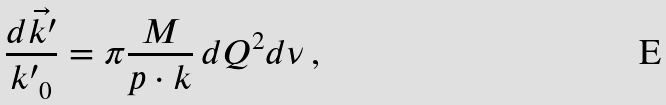<formula> <loc_0><loc_0><loc_500><loc_500>\frac { d \vec { k ^ { \prime } } } { { k ^ { \prime } } _ { 0 } } = \pi \frac { M } { p \cdot k } \, d Q ^ { 2 } d \nu \, ,</formula> 